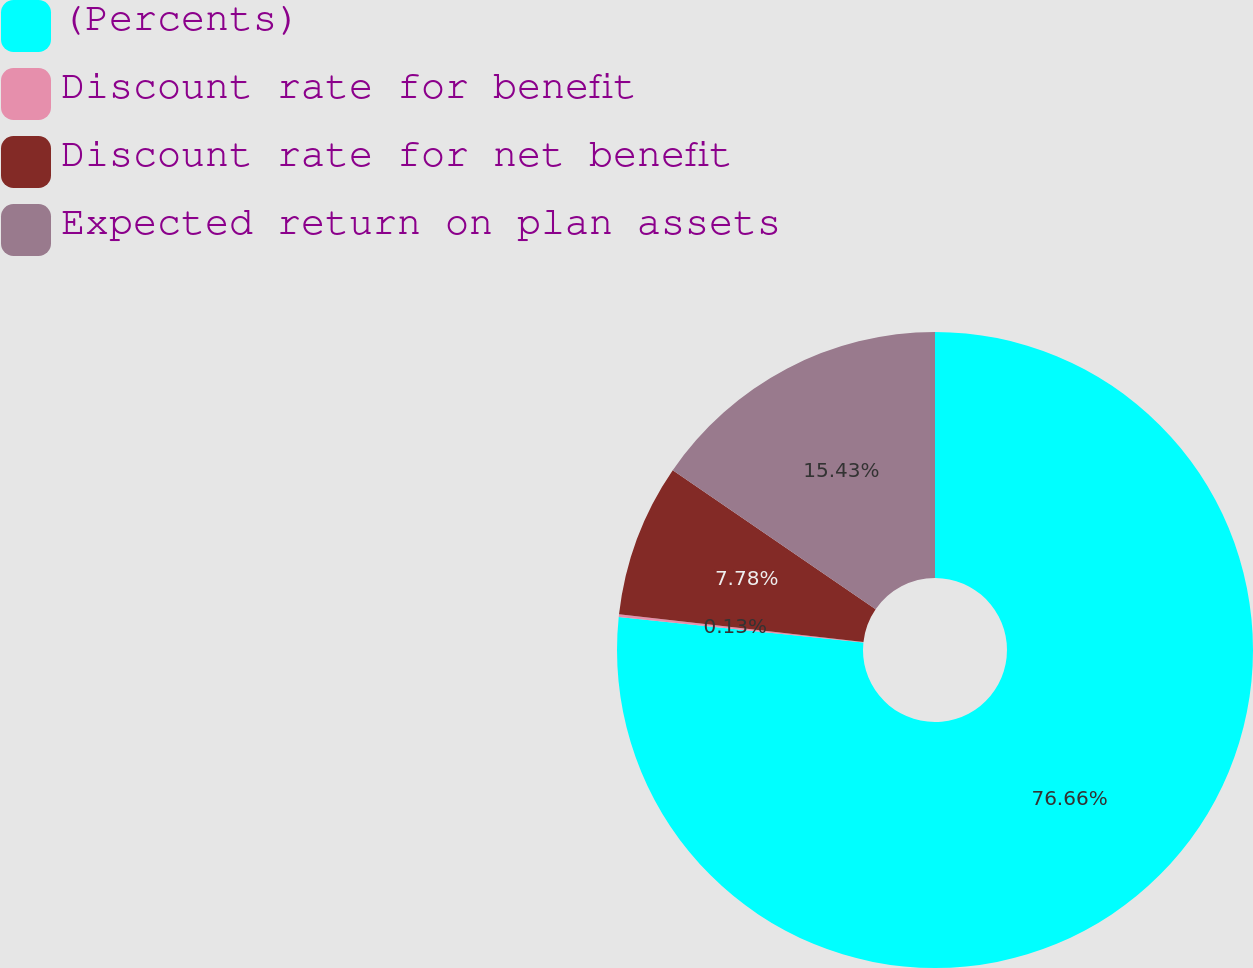Convert chart to OTSL. <chart><loc_0><loc_0><loc_500><loc_500><pie_chart><fcel>(Percents)<fcel>Discount rate for benefit<fcel>Discount rate for net benefit<fcel>Expected return on plan assets<nl><fcel>76.65%<fcel>0.13%<fcel>7.78%<fcel>15.43%<nl></chart> 